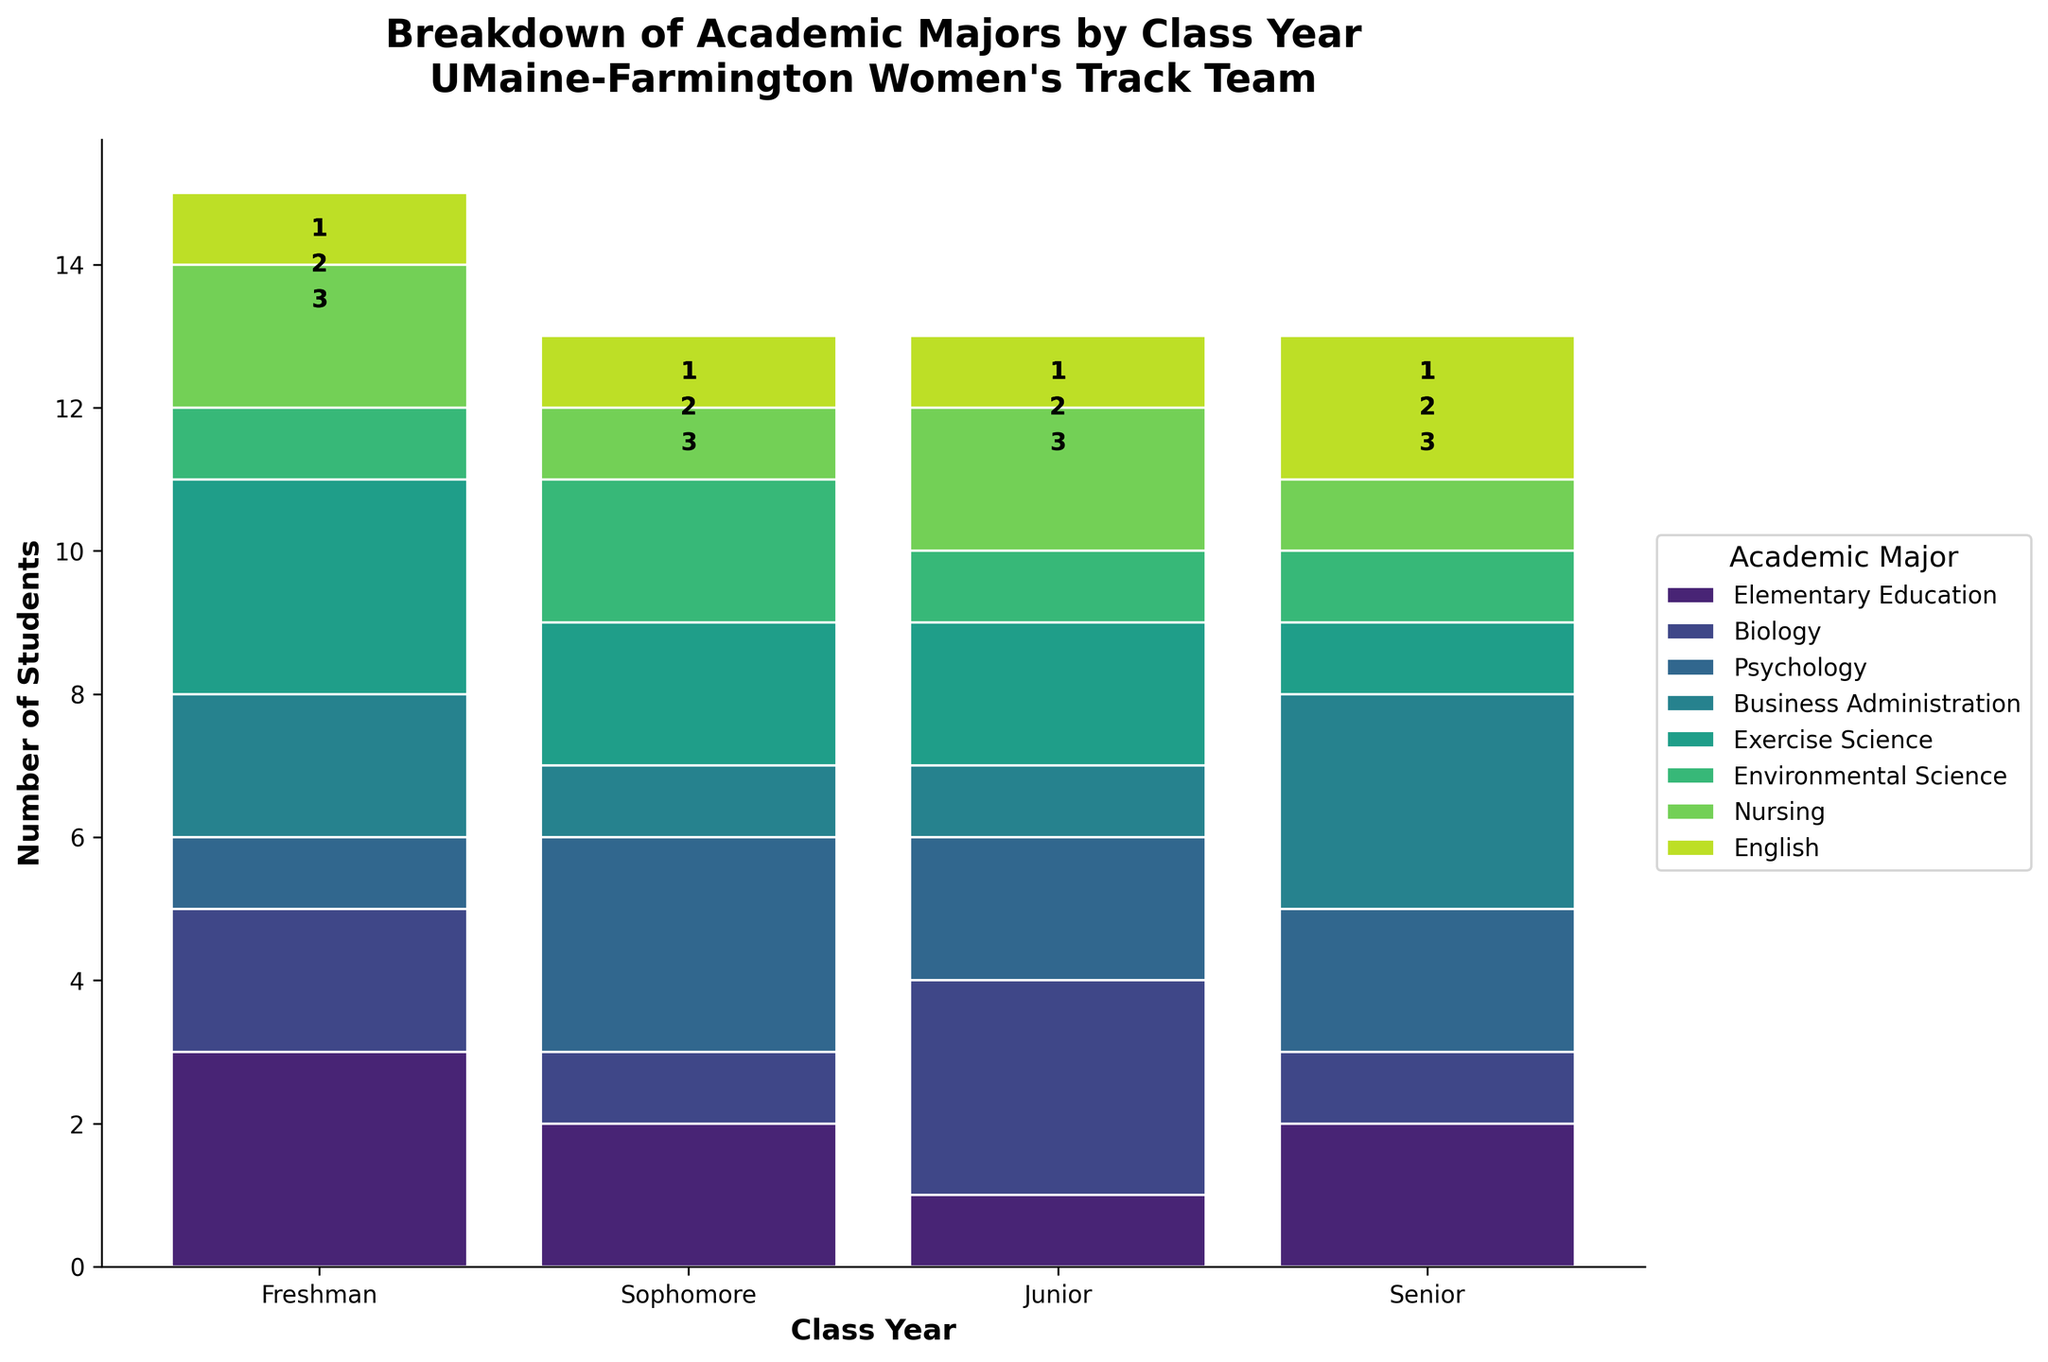How many students are majoring in Psychology in their sophomore year? Look at the bar height for Psychology within the Sophomore section.
Answer: 3 Which academic major has the highest number of juniors? Compare the heights of the bars in the Junior category for each major. Exercise Science has the tallest bar in the Junior category.
Answer: Exercise Science How many total Senior students are there across all majors? Sum up the heights of all the bars in the Senior category. (2+1+2+3+1+1+1+2) = 13
Answer: 13 Compare the number of Freshmen studying Biology to those studying Nursing. Who has more? Examine the bar heights for Freshmen majoring in Biology and Nursing. Biology has a height of 2, and Nursing has a height of 2. So they have the same number.
Answer: Same Which academic major has the fewest Freshmen? Look for the shortest bar in the Freshmen category. Environmental Science and English both have 1 Freshman, which is the least.
Answer: Environmental Science & English How many total students are majoring in Exercise Science? Sum up the heights of the bars for all class years under Exercise Science. (3+2+2+1) = 8
Answer: 8 Is the number of students majoring in Elementary Education greater in the Freshman or Junior Year? Compare the bar heights for Elementary Education in the Freshman and Junior categories. Freshman has 3, Junior has 1.
Answer: Freshman What is the total number of students majoring in English across all class years? Add the numbers from the English category in each class year. (1+1+1+2) = 5
Answer: 5 Which class year has the most students majoring in Business Administration? Compare the heights of the bars for Business Administration across all class years. Senior has the tallest bar.
Answer: Senior How many more students are majoring in Psychology than in Nursing for the Junior class? Subtract the bar height of Nursing in Junior from that of Psychology in Junior. 2 - 2 = 0
Answer: 0 